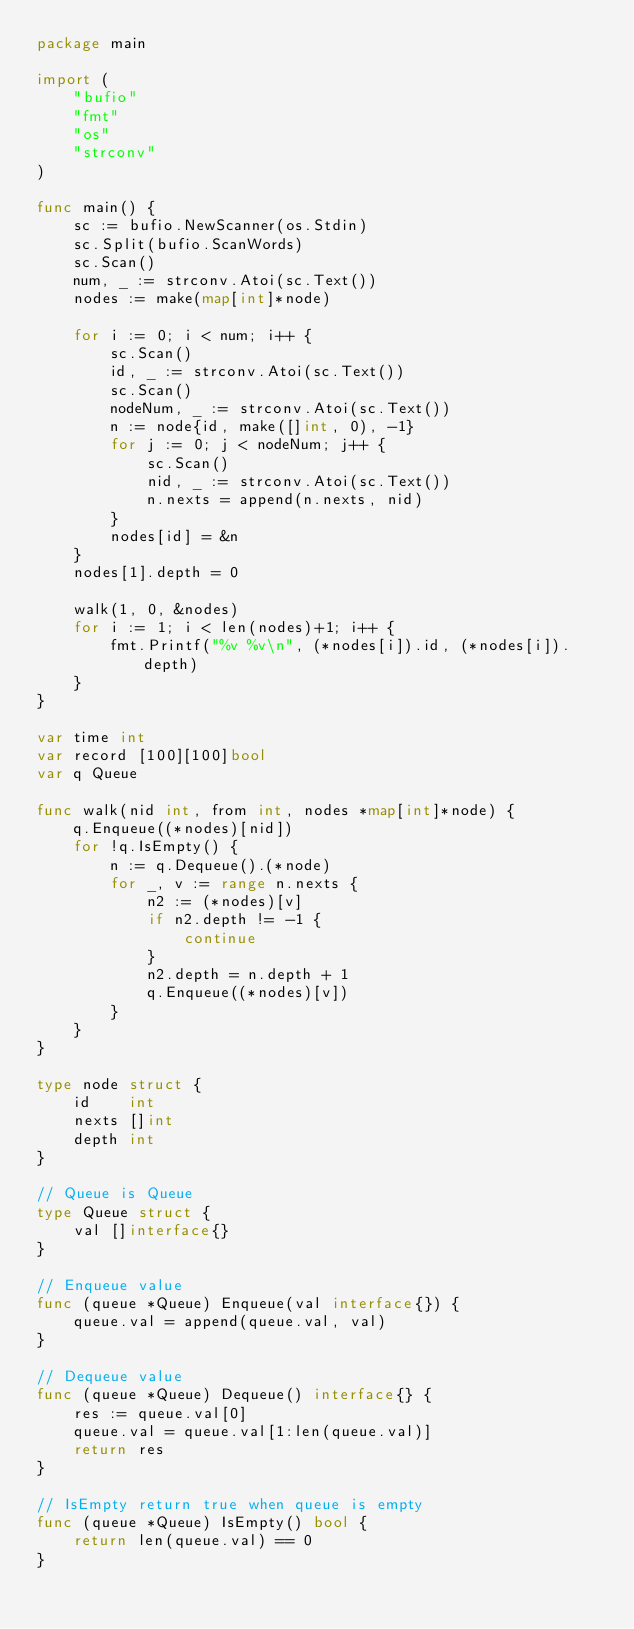<code> <loc_0><loc_0><loc_500><loc_500><_Go_>package main

import (
	"bufio"
	"fmt"
	"os"
	"strconv"
)

func main() {
	sc := bufio.NewScanner(os.Stdin)
	sc.Split(bufio.ScanWords)
	sc.Scan()
	num, _ := strconv.Atoi(sc.Text())
	nodes := make(map[int]*node)

	for i := 0; i < num; i++ {
		sc.Scan()
		id, _ := strconv.Atoi(sc.Text())
		sc.Scan()
		nodeNum, _ := strconv.Atoi(sc.Text())
		n := node{id, make([]int, 0), -1}
		for j := 0; j < nodeNum; j++ {
			sc.Scan()
			nid, _ := strconv.Atoi(sc.Text())
			n.nexts = append(n.nexts, nid)
		}
		nodes[id] = &n
	}
	nodes[1].depth = 0

	walk(1, 0, &nodes)
	for i := 1; i < len(nodes)+1; i++ {
		fmt.Printf("%v %v\n", (*nodes[i]).id, (*nodes[i]).depth)
	}
}

var time int
var record [100][100]bool
var q Queue

func walk(nid int, from int, nodes *map[int]*node) {
	q.Enqueue((*nodes)[nid])
	for !q.IsEmpty() {
		n := q.Dequeue().(*node)
		for _, v := range n.nexts {
			n2 := (*nodes)[v]
			if n2.depth != -1 {
				continue
			}
			n2.depth = n.depth + 1
			q.Enqueue((*nodes)[v])
		}
	}
}

type node struct {
	id    int
	nexts []int
	depth int
}

// Queue is Queue
type Queue struct {
	val []interface{}
}

// Enqueue value
func (queue *Queue) Enqueue(val interface{}) {
	queue.val = append(queue.val, val)
}

// Dequeue value
func (queue *Queue) Dequeue() interface{} {
	res := queue.val[0]
	queue.val = queue.val[1:len(queue.val)]
	return res
}

// IsEmpty return true when queue is empty
func (queue *Queue) IsEmpty() bool {
	return len(queue.val) == 0
}

</code> 